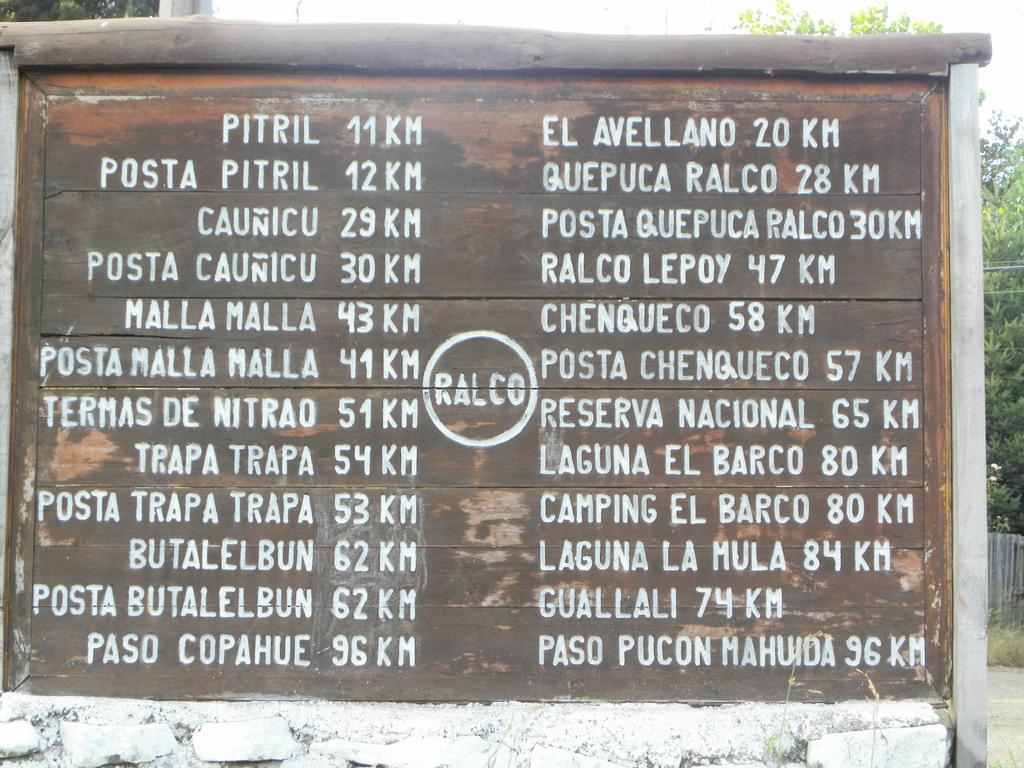What is on the board that is visible in the image? There is a board with text in the image. What can be seen in the background of the image? There are trees and the sky visible in the background of the image. What type of vegetable is being harvested in the image? There is no vegetable being harvested in the image; it features a board with text and a background with trees and the sky. 